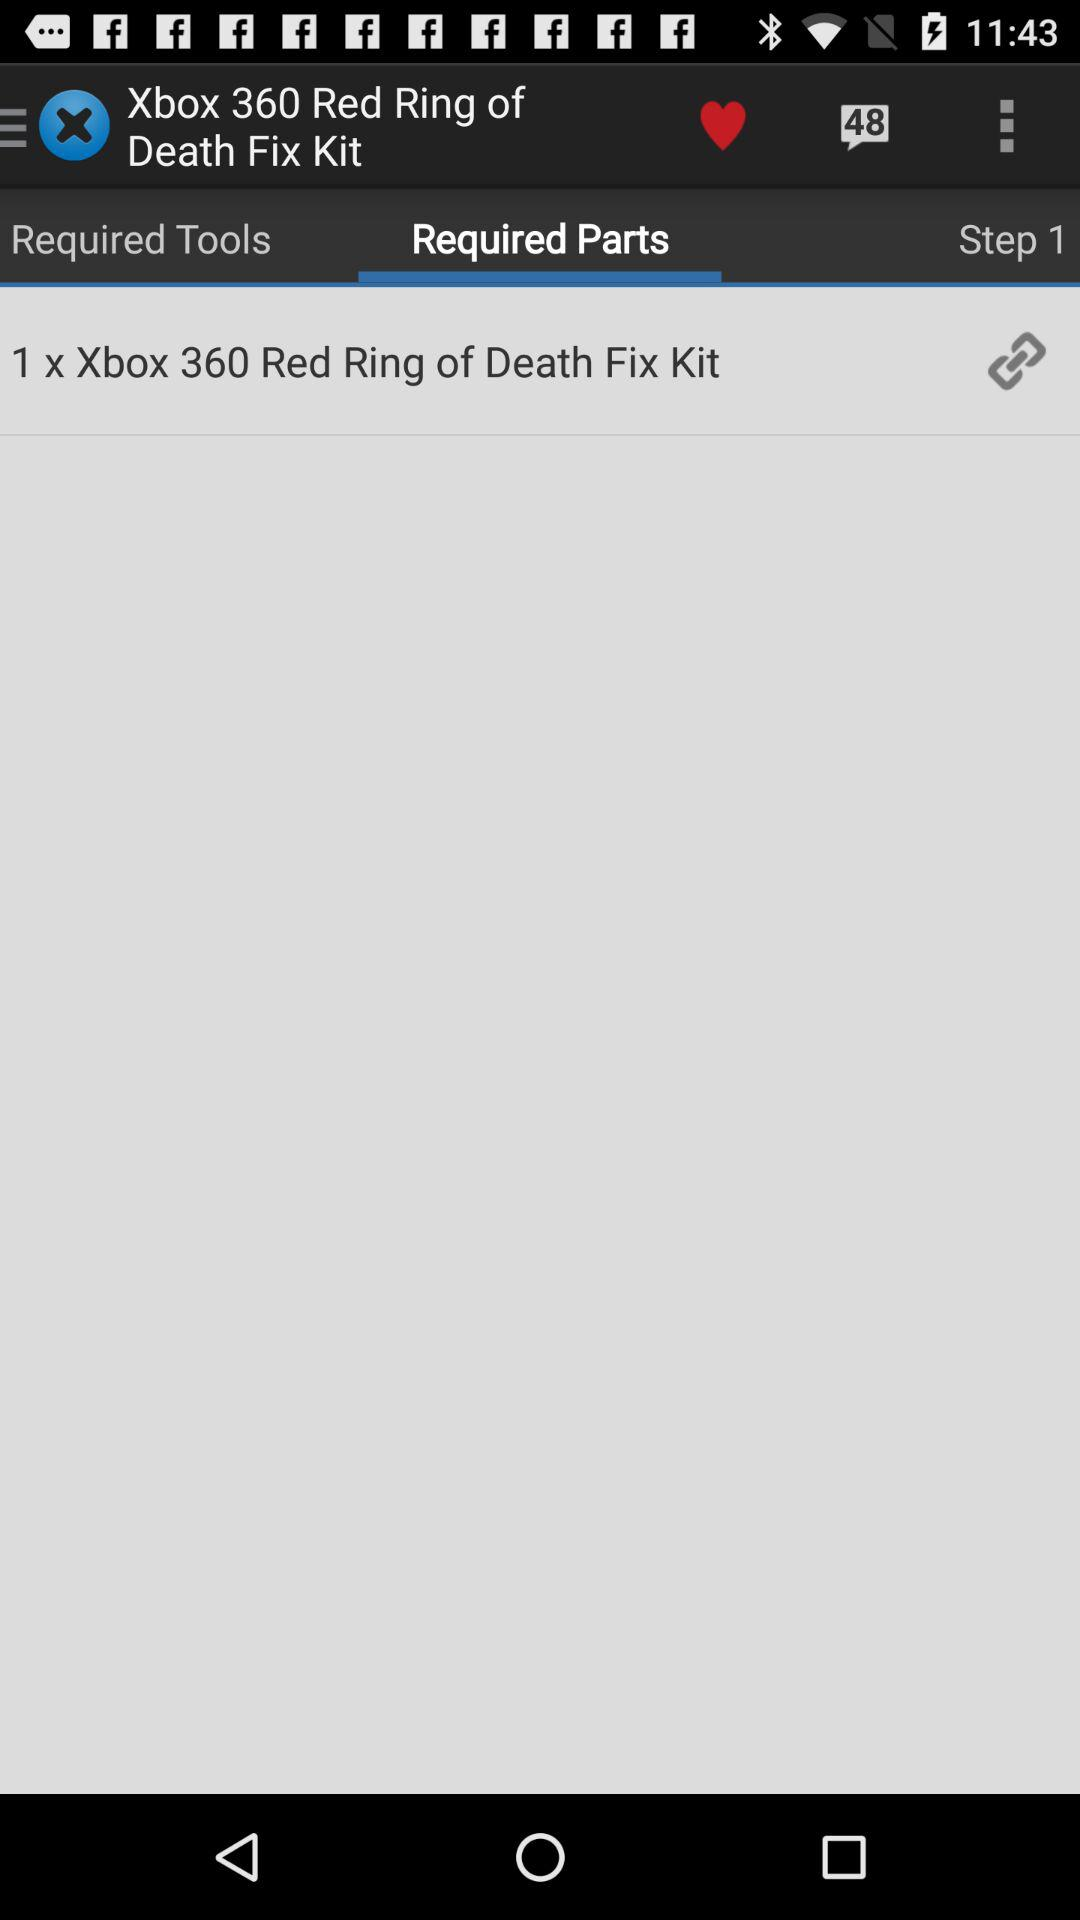How many unread messages are there?
When the provided information is insufficient, respond with <no answer>. <no answer> 